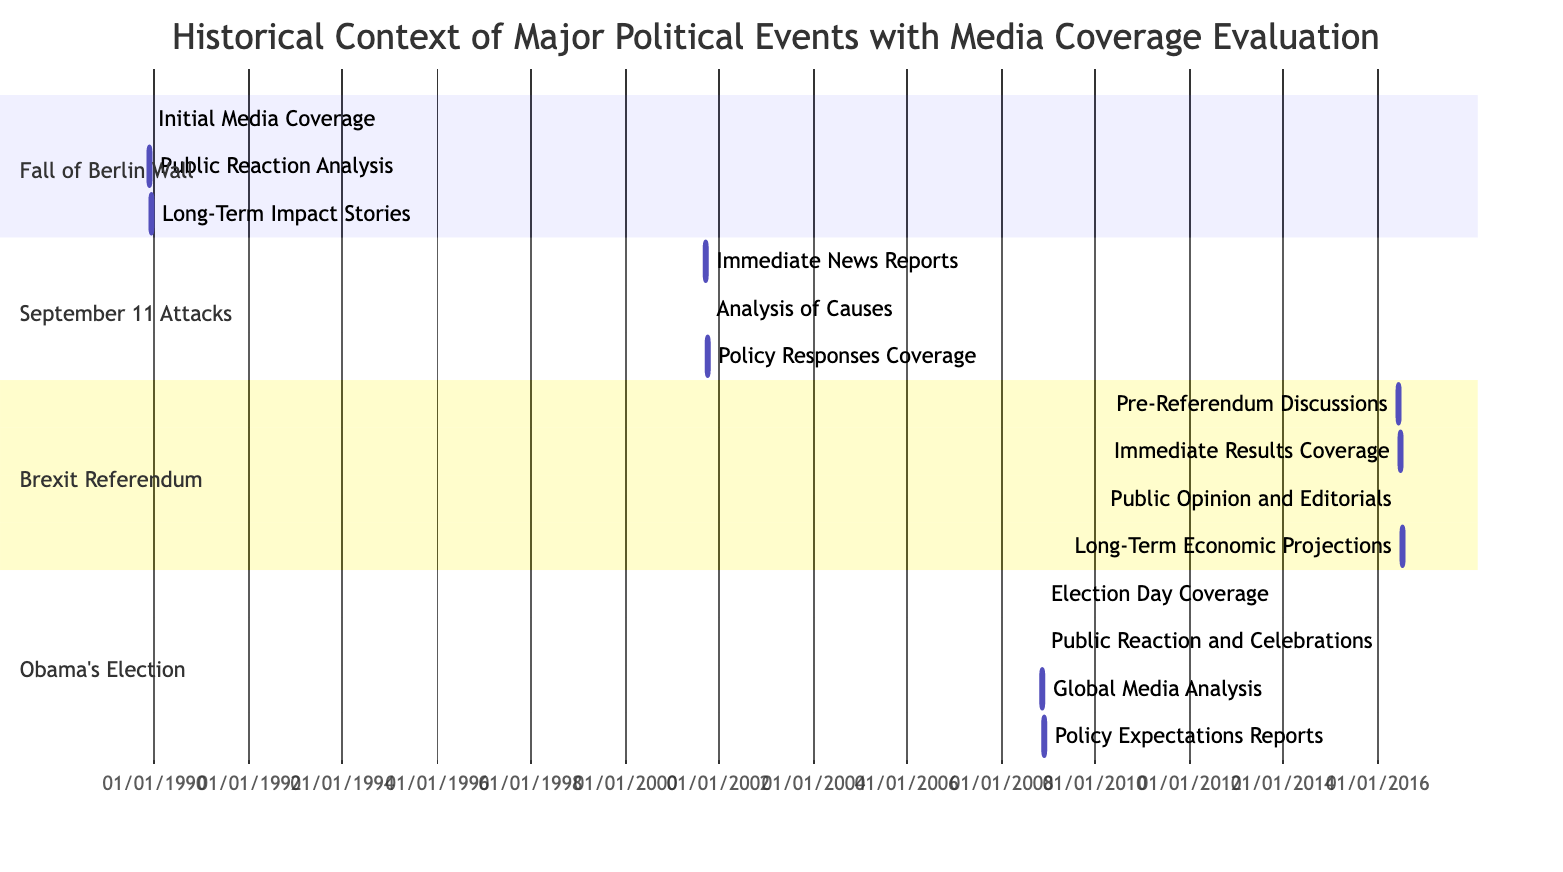What is the duration of the media coverage for the Fall of the Berlin Wall? The media coverage starts on November 9, 1989, and ends on December 9, 1989. The total duration is calculated by finding the difference between the end date and start date, which is 30 days.
Answer: 30 days Which event had the longest period of initial media coverage? By examining the duration of each initial media coverage task, the Fall of the Berlin Wall (6 days) and the September 11 Attacks (9 days) are compared. The initial media coverage for the September 11 Attacks lasts longer than that of the Fall of the Berlin Wall.
Answer: September 11 Attacks How many tasks are there for the Brexit Referendum? The Gantt chart shows four distinct tasks listed under the Brexit Referendum section: Pre-Referendum Discussions, Immediate Results Coverage, Public Opinion and Editorials, and Long-Term Economic Projections. Adding these tasks together gives the total number of tasks.
Answer: 4 tasks What task follows immediately after the Public Reaction and Celebrations for Obama's Election? The task that follows is the Global Media Analysis, which starts on November 14, 2008, immediately after the end of the Public Reaction and Celebrations task on November 14, 2008.
Answer: Global Media Analysis What is the last task for the September 11 Attacks? The last task is Policy Responses Coverage, which is scheduled to end on October 11, 2001. This can be identified by looking at the tasks listed in this section and their respective end dates.
Answer: Policy Responses Coverage Which event had an analysis period after initial coverage that spanned the next 5 days? For the Fall of the Berlin Wall, the Public Reaction Analysis spans from November 15 to November 20, 1989, which accounts for exactly 5 days following the initial media coverage. This is confirmed by checking the timeline of this event's coverage tasks.
Answer: Fall of the Berlin Wall How does the timeline for the Long-Term Economic Projections task compare to the tasks under the Obama’s Election section? The Long-Term Economic Projections task runs from July 10, 2016, to July 23, 2016, whereas the tasks under the Obama’s Election section occur in November 2008. Since the Obama’s Election section has tasks in a different month, none of the tasks overlap with the Long-Term Economic Projections.
Answer: No overlap Which event had initial media coverage starting and ending in the same month? The initial media coverage for the Fall of the Berlin Wall starts on November 9, 1989, and ends on November 15, 1989, which means both dates fall within the same month of November 1989. This can be determined by checking the scheduling of this event's tasks.
Answer: Fall of the Berlin Wall 